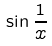Convert formula to latex. <formula><loc_0><loc_0><loc_500><loc_500>\sin \frac { 1 } { x }</formula> 